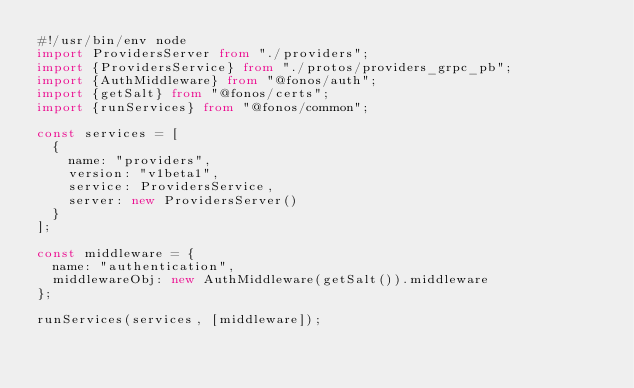Convert code to text. <code><loc_0><loc_0><loc_500><loc_500><_TypeScript_>#!/usr/bin/env node
import ProvidersServer from "./providers";
import {ProvidersService} from "./protos/providers_grpc_pb";
import {AuthMiddleware} from "@fonos/auth";
import {getSalt} from "@fonos/certs";
import {runServices} from "@fonos/common";

const services = [
  {
    name: "providers",
    version: "v1beta1",
    service: ProvidersService,
    server: new ProvidersServer()
  }
];

const middleware = {
  name: "authentication",
  middlewareObj: new AuthMiddleware(getSalt()).middleware
};

runServices(services, [middleware]);
</code> 